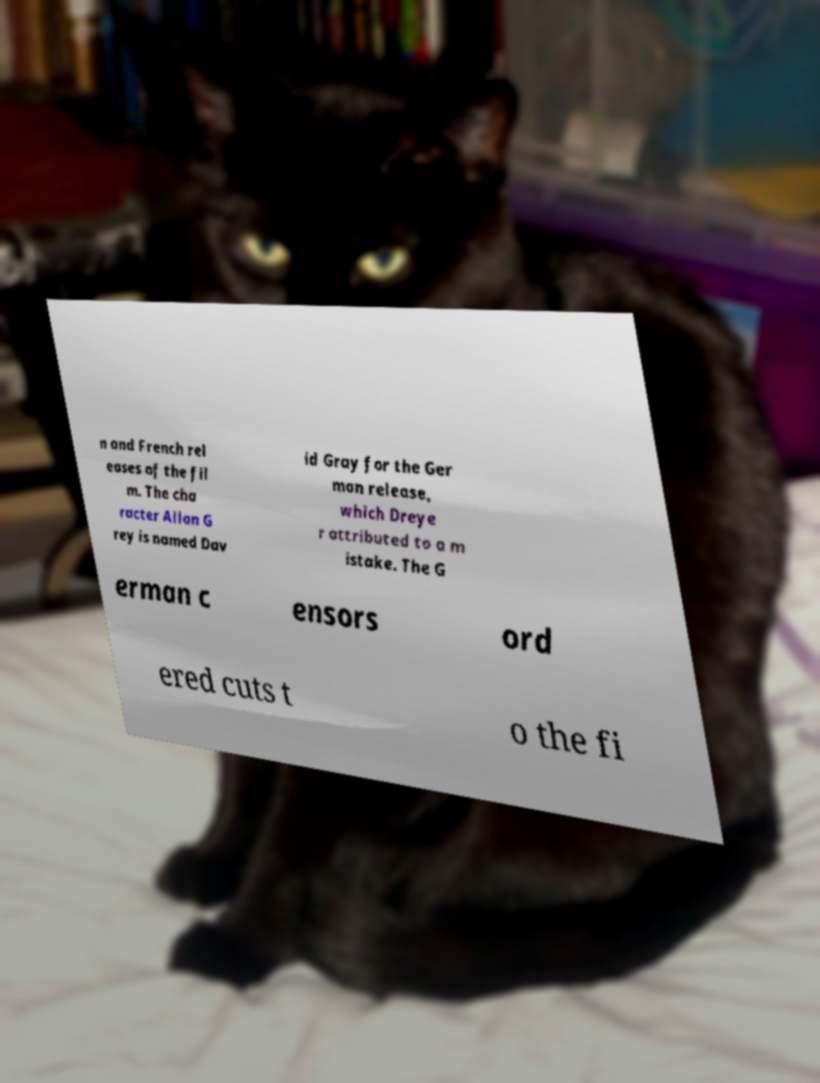Please identify and transcribe the text found in this image. n and French rel eases of the fil m. The cha racter Allan G rey is named Dav id Gray for the Ger man release, which Dreye r attributed to a m istake. The G erman c ensors ord ered cuts t o the fi 